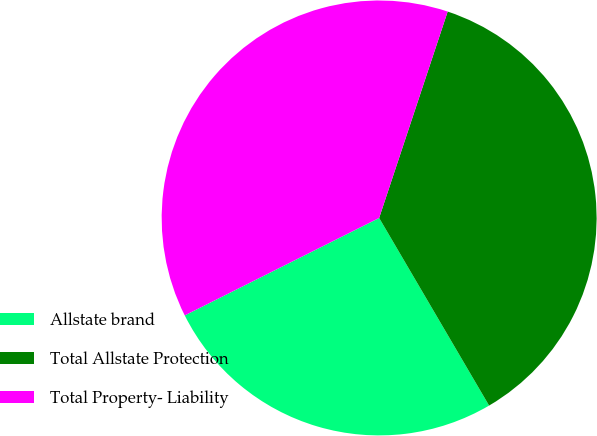<chart> <loc_0><loc_0><loc_500><loc_500><pie_chart><fcel>Allstate brand<fcel>Total Allstate Protection<fcel>Total Property- Liability<nl><fcel>26.04%<fcel>36.46%<fcel>37.5%<nl></chart> 